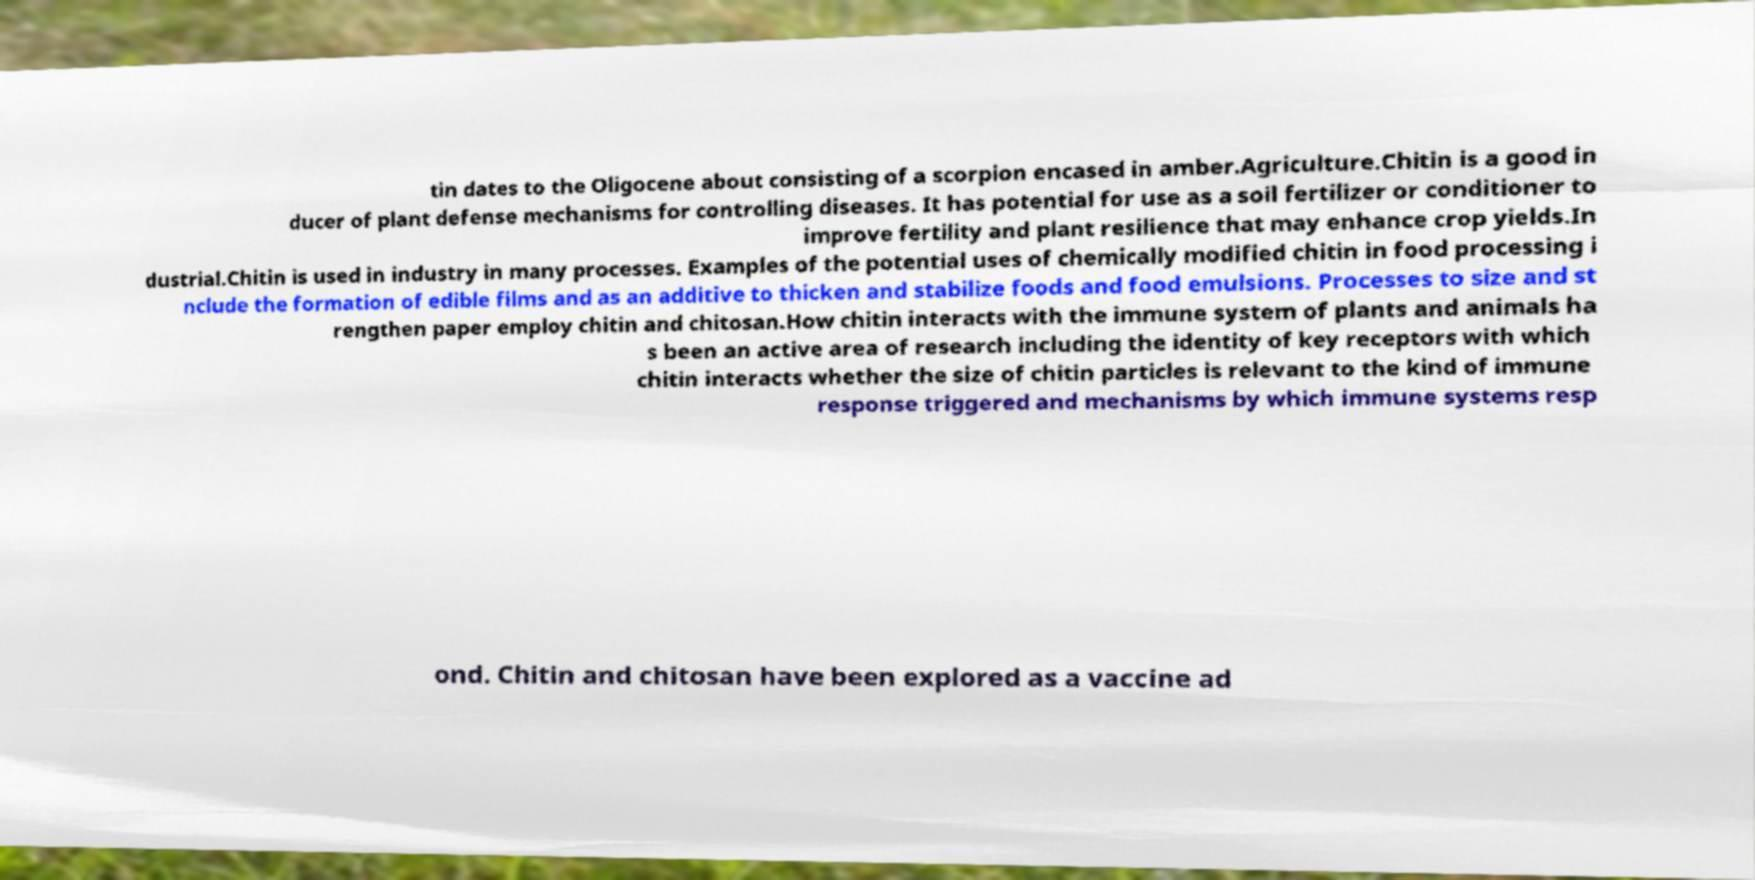I need the written content from this picture converted into text. Can you do that? tin dates to the Oligocene about consisting of a scorpion encased in amber.Agriculture.Chitin is a good in ducer of plant defense mechanisms for controlling diseases. It has potential for use as a soil fertilizer or conditioner to improve fertility and plant resilience that may enhance crop yields.In dustrial.Chitin is used in industry in many processes. Examples of the potential uses of chemically modified chitin in food processing i nclude the formation of edible films and as an additive to thicken and stabilize foods and food emulsions. Processes to size and st rengthen paper employ chitin and chitosan.How chitin interacts with the immune system of plants and animals ha s been an active area of research including the identity of key receptors with which chitin interacts whether the size of chitin particles is relevant to the kind of immune response triggered and mechanisms by which immune systems resp ond. Chitin and chitosan have been explored as a vaccine ad 